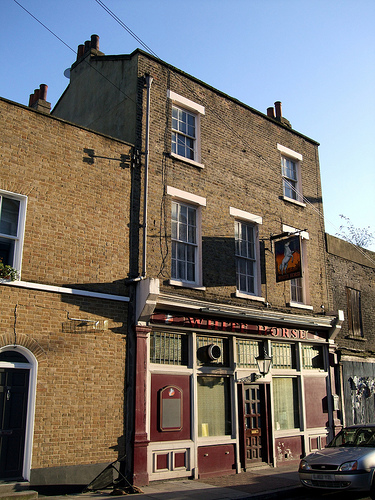<image>
Is the window next to the window? No. The window is not positioned next to the window. They are located in different areas of the scene. Is there a sky above the building? Yes. The sky is positioned above the building in the vertical space, higher up in the scene. 